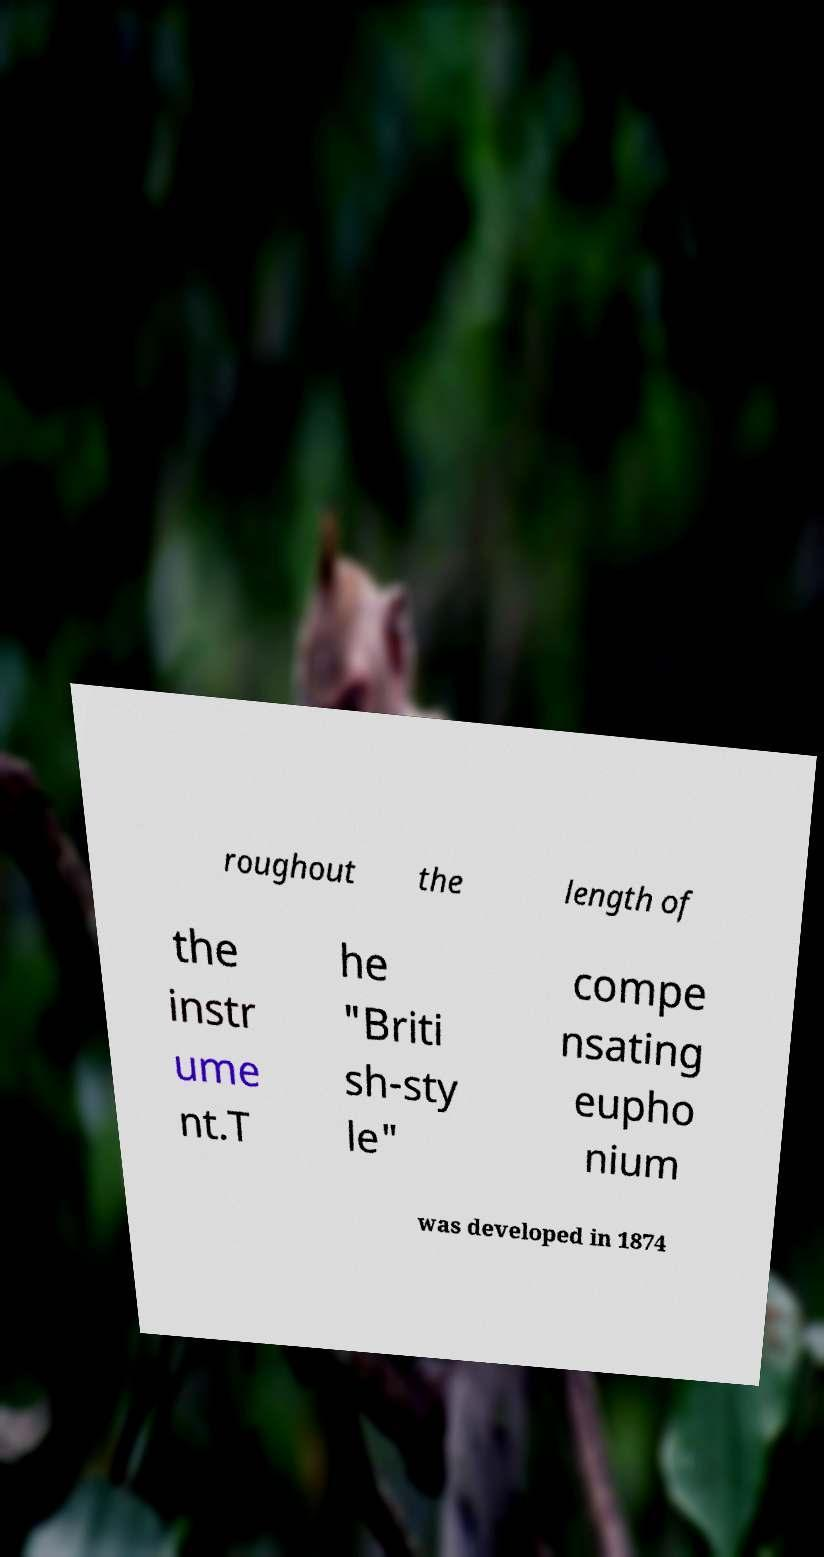I need the written content from this picture converted into text. Can you do that? roughout the length of the instr ume nt.T he "Briti sh-sty le" compe nsating eupho nium was developed in 1874 